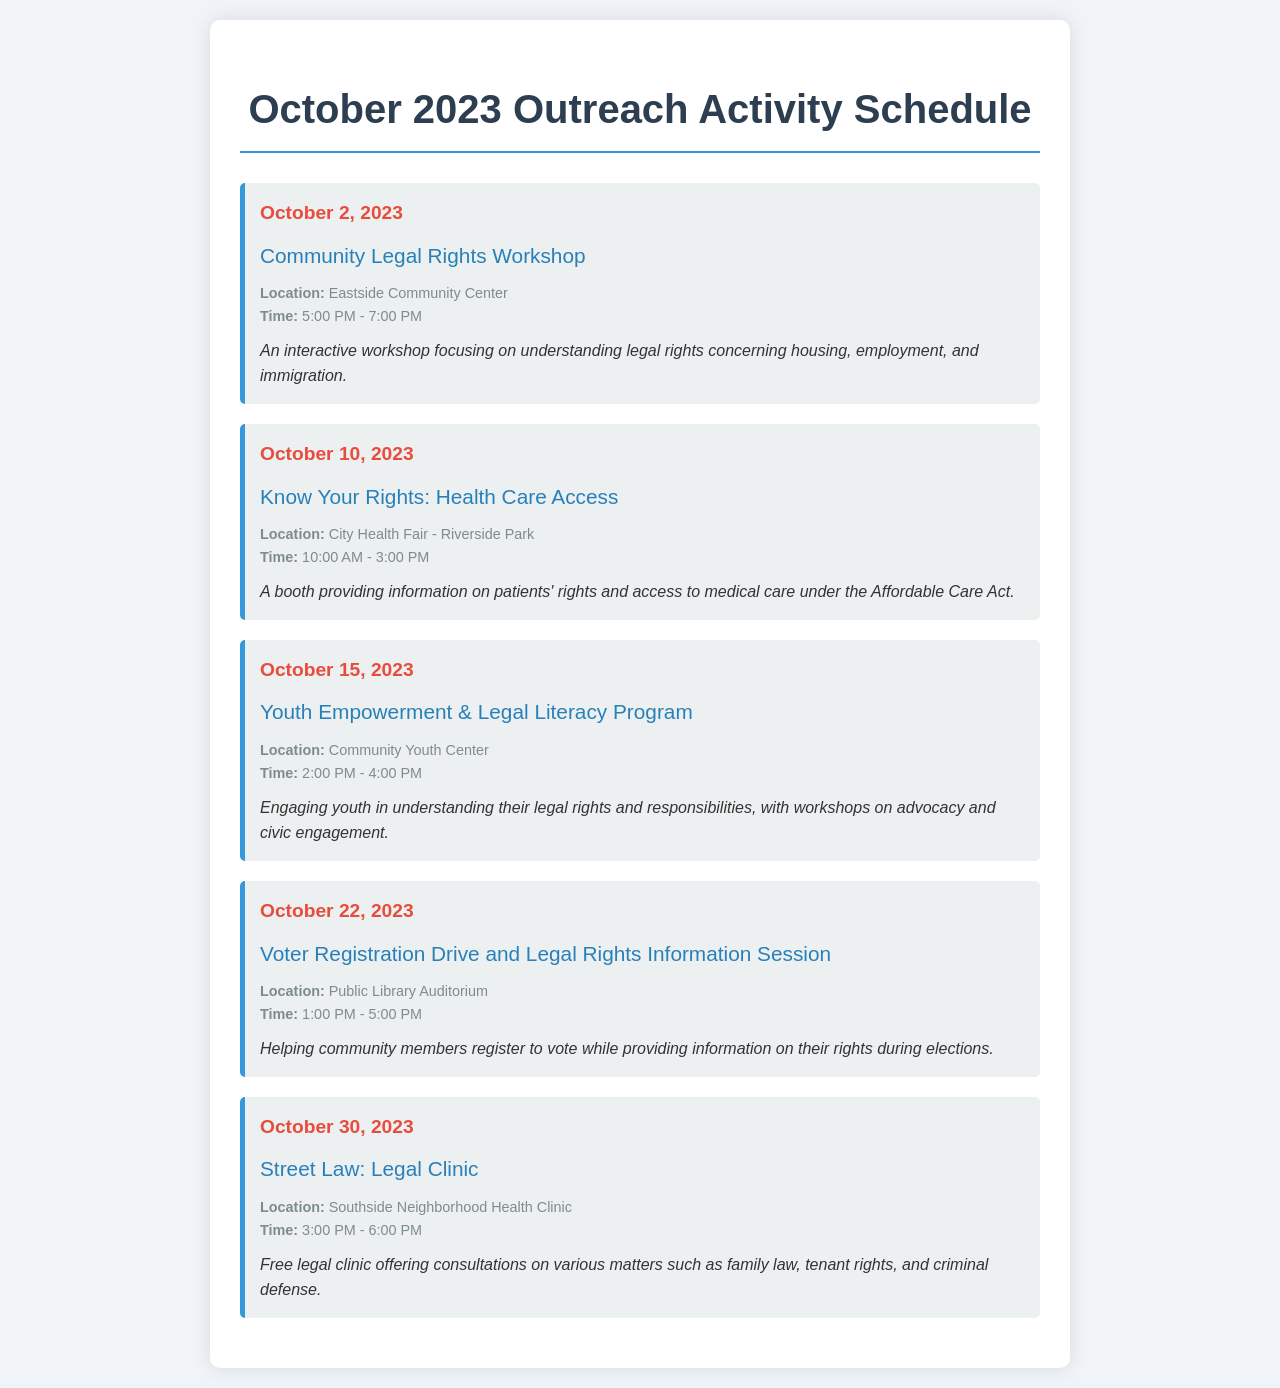What is the title of the first event? The title is found in the first event section of the schedule, which is "Community Legal Rights Workshop".
Answer: Community Legal Rights Workshop When is the "Know Your Rights: Health Care Access" event scheduled? The date for this event is explicitly mentioned as October 10, 2023.
Answer: October 10, 2023 Where will the Youth Empowerment & Legal Literacy Program take place? The location is stated in the event details, which is "Community Youth Center".
Answer: Community Youth Center What time does the Voter Registration Drive start? The time is provided in the event details, specifically mentioned as "1:00 PM".
Answer: 1:00 PM How long is the Street Law: Legal Clinic event? The duration can be calculated based on the start and end times provided in the event details, which are from 3:00 PM to 6:00 PM, indicating a duration of 3 hours.
Answer: 3 hours Which event focuses on youth engagement? The event title specifies focus on youth, which is "Youth Empowerment & Legal Literacy Program".
Answer: Youth Empowerment & Legal Literacy Program What type of service is offered at the Street Law: Legal Clinic? The document mentions it offers free legal consultations on various matters, which indicates the nature of service.
Answer: Free legal consultations What is the purpose of the Voter Registration Drive? The purpose is to help community members register to vote while providing information on their rights, as stated in the event description.
Answer: Helping community members register to vote What is the end time for the Community Legal Rights Workshop? The end time is given in the event details, marking the conclusion at "7:00 PM".
Answer: 7:00 PM 